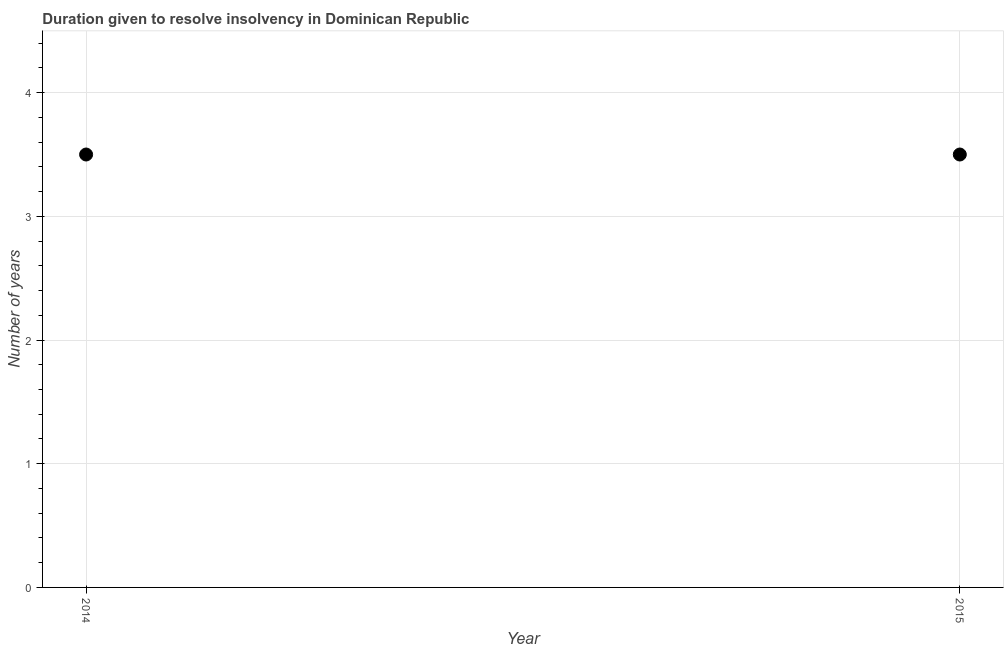Across all years, what is the maximum number of years to resolve insolvency?
Offer a terse response. 3.5. In which year was the number of years to resolve insolvency maximum?
Your answer should be very brief. 2014. In which year was the number of years to resolve insolvency minimum?
Ensure brevity in your answer.  2014. What is the average number of years to resolve insolvency per year?
Your response must be concise. 3.5. In how many years, is the number of years to resolve insolvency greater than 2 ?
Ensure brevity in your answer.  2. What is the ratio of the number of years to resolve insolvency in 2014 to that in 2015?
Your response must be concise. 1. Is the number of years to resolve insolvency in 2014 less than that in 2015?
Your answer should be compact. No. Does the number of years to resolve insolvency monotonically increase over the years?
Your answer should be compact. No. How many dotlines are there?
Offer a very short reply. 1. How many years are there in the graph?
Give a very brief answer. 2. What is the title of the graph?
Give a very brief answer. Duration given to resolve insolvency in Dominican Republic. What is the label or title of the X-axis?
Offer a terse response. Year. What is the label or title of the Y-axis?
Give a very brief answer. Number of years. What is the Number of years in 2014?
Offer a very short reply. 3.5. What is the Number of years in 2015?
Your answer should be very brief. 3.5. What is the ratio of the Number of years in 2014 to that in 2015?
Your response must be concise. 1. 